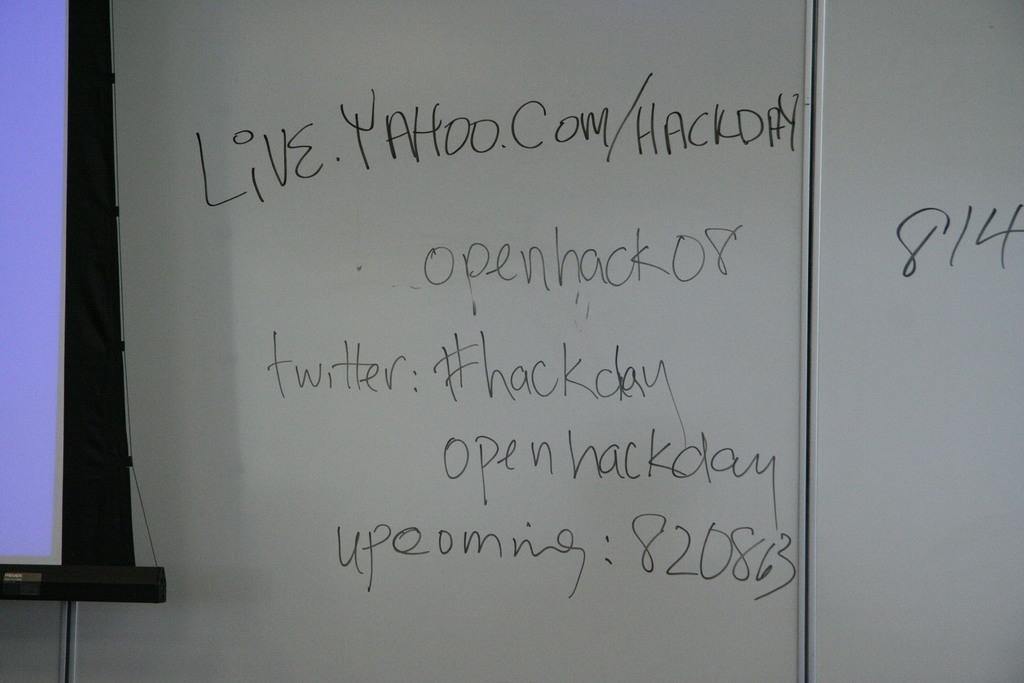<image>
Share a concise interpretation of the image provided. A whiteboard with Live.yahoo.com written on it in black. 